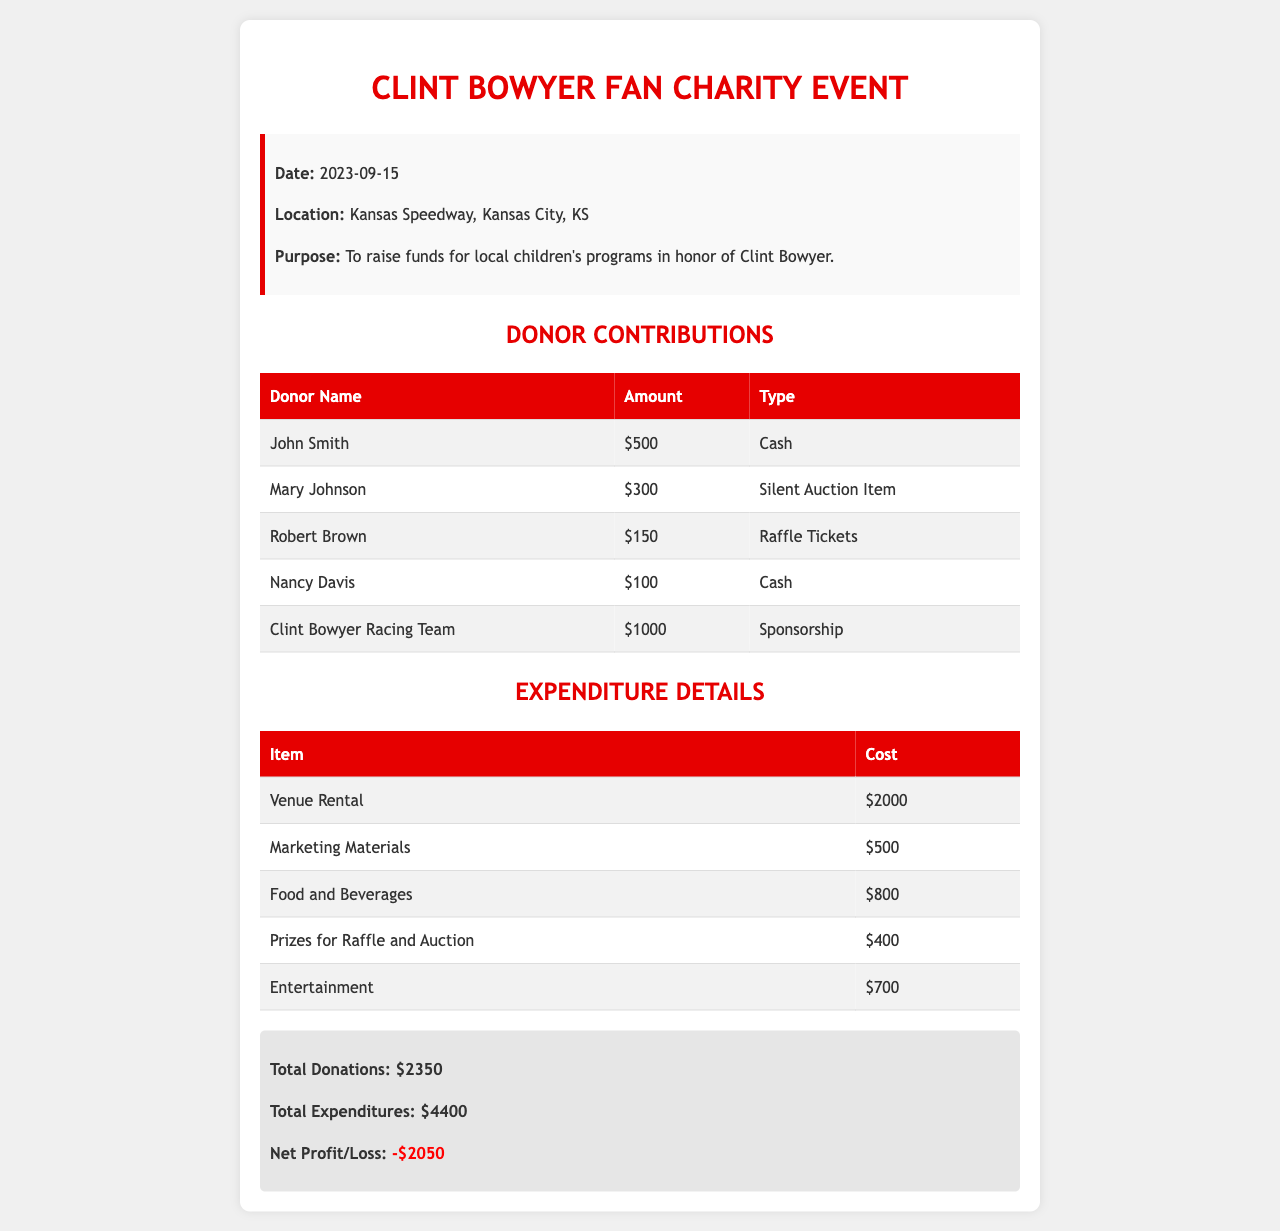What was the date of the event? The date of the event is specified in the event details section of the document.
Answer: 2023-09-15 Where was the event held? The location of the event is mentioned in the event details section.
Answer: Kansas Speedway, Kansas City, KS How much did Clint Bowyer Racing Team contribute? The contribution amount from Clint Bowyer Racing Team is listed among the donors.
Answer: $1000 What is the total amount collected from donations? The total donations amount is summarized at the end of the document.
Answer: $2350 What was the cost of the venue rental? The expenditure for the venue rental is provided in the expenditure details.
Answer: $2000 How much did the event lose in total? The net profit/loss figure summarizes the financial outcome at the end of the document.
Answer: -$2050 What type of contribution did Mary Johnson make? The type of Mary's contribution is listed beside her name in the donor contributions table.
Answer: Silent Auction Item Which item had the highest expenditure? The item with the highest cost is mentioned in the expenditure details.
Answer: Venue Rental What purpose of the event is described? The purpose of the event is outlined in the event details section.
Answer: To raise funds for local children's programs in honor of Clint Bowyer 